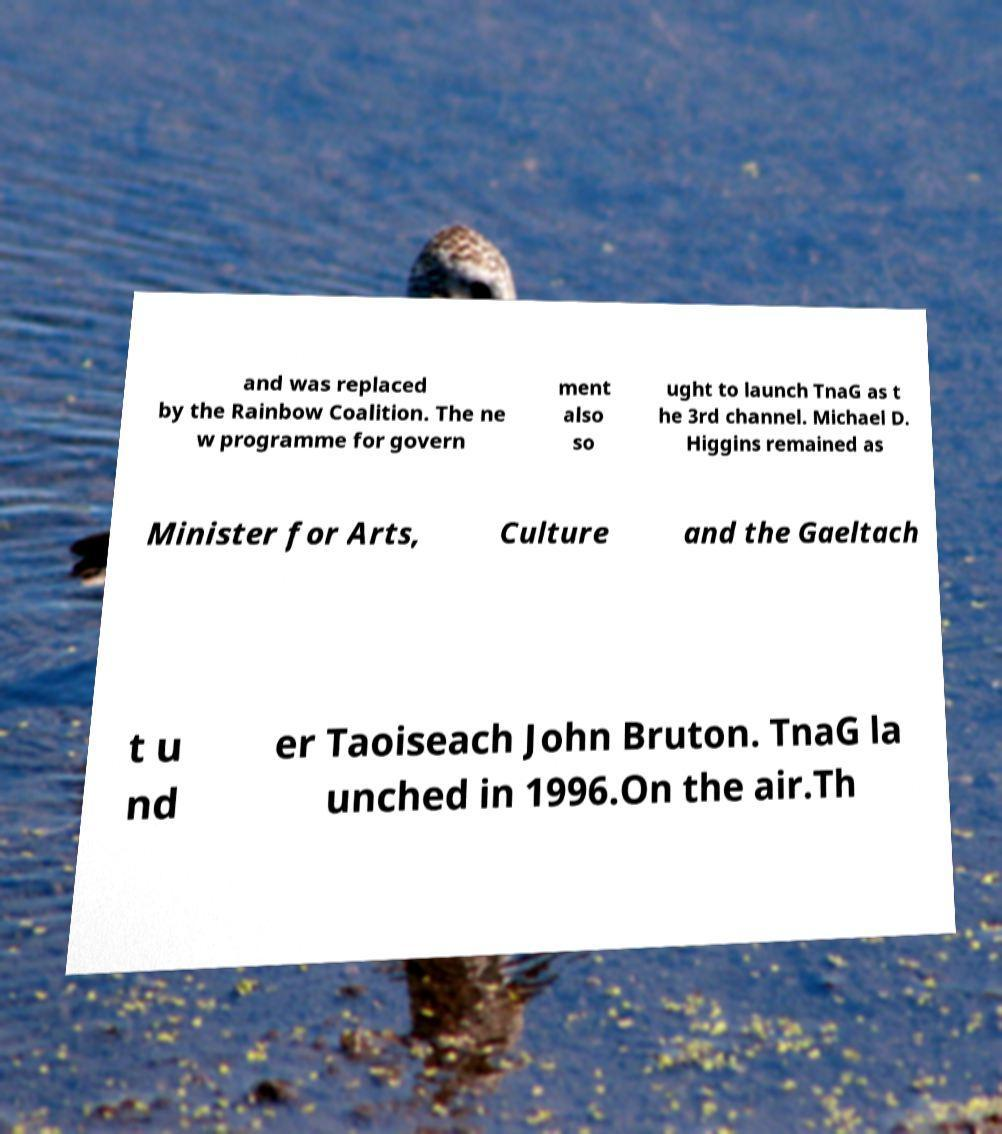For documentation purposes, I need the text within this image transcribed. Could you provide that? and was replaced by the Rainbow Coalition. The ne w programme for govern ment also so ught to launch TnaG as t he 3rd channel. Michael D. Higgins remained as Minister for Arts, Culture and the Gaeltach t u nd er Taoiseach John Bruton. TnaG la unched in 1996.On the air.Th 